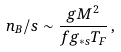Convert formula to latex. <formula><loc_0><loc_0><loc_500><loc_500>n _ { B } / s \sim \frac { g M ^ { 2 } } { f g _ { \ast s } T _ { F } } \, ,</formula> 